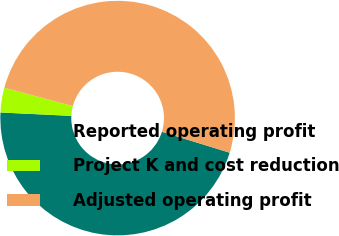Convert chart to OTSL. <chart><loc_0><loc_0><loc_500><loc_500><pie_chart><fcel>Reported operating profit<fcel>Project K and cost reduction<fcel>Adjusted operating profit<nl><fcel>46.0%<fcel>3.41%<fcel>50.6%<nl></chart> 